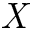<formula> <loc_0><loc_0><loc_500><loc_500>X</formula> 